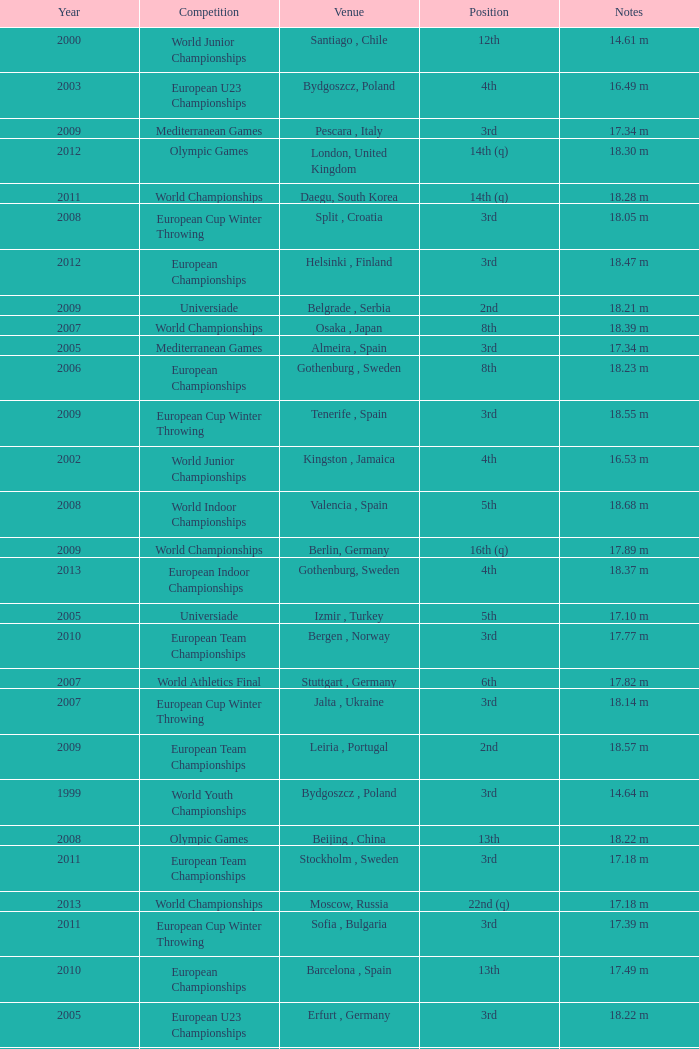What position is 1999? 3rd. 